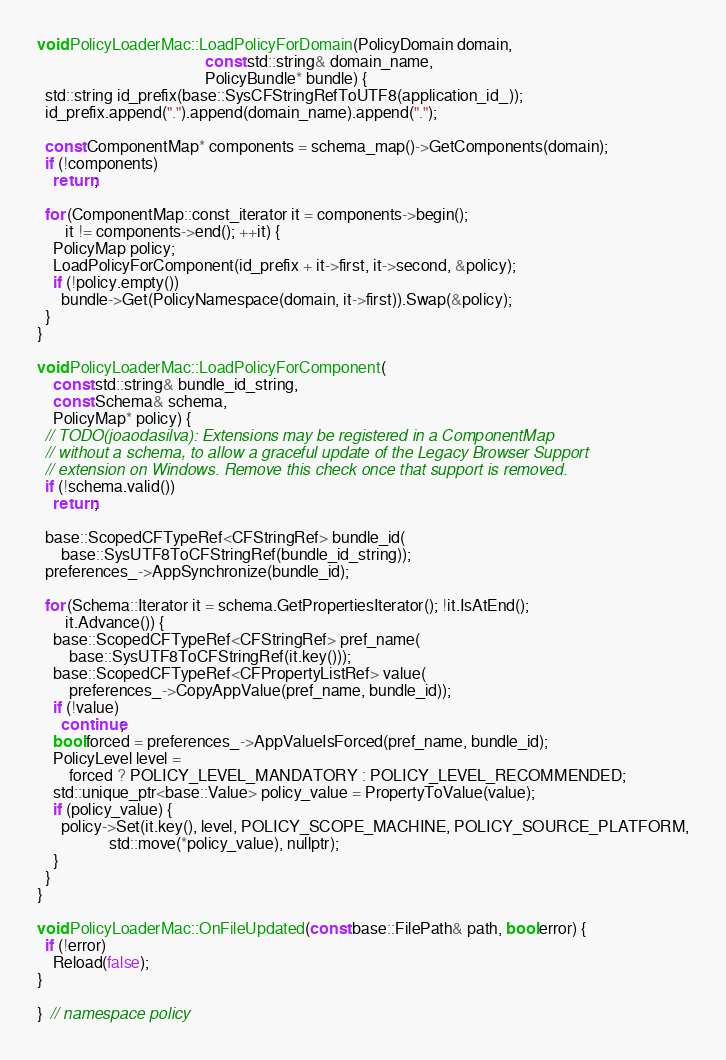Convert code to text. <code><loc_0><loc_0><loc_500><loc_500><_ObjectiveC_>void PolicyLoaderMac::LoadPolicyForDomain(PolicyDomain domain,
                                          const std::string& domain_name,
                                          PolicyBundle* bundle) {
  std::string id_prefix(base::SysCFStringRefToUTF8(application_id_));
  id_prefix.append(".").append(domain_name).append(".");

  const ComponentMap* components = schema_map()->GetComponents(domain);
  if (!components)
    return;

  for (ComponentMap::const_iterator it = components->begin();
       it != components->end(); ++it) {
    PolicyMap policy;
    LoadPolicyForComponent(id_prefix + it->first, it->second, &policy);
    if (!policy.empty())
      bundle->Get(PolicyNamespace(domain, it->first)).Swap(&policy);
  }
}

void PolicyLoaderMac::LoadPolicyForComponent(
    const std::string& bundle_id_string,
    const Schema& schema,
    PolicyMap* policy) {
  // TODO(joaodasilva): Extensions may be registered in a ComponentMap
  // without a schema, to allow a graceful update of the Legacy Browser Support
  // extension on Windows. Remove this check once that support is removed.
  if (!schema.valid())
    return;

  base::ScopedCFTypeRef<CFStringRef> bundle_id(
      base::SysUTF8ToCFStringRef(bundle_id_string));
  preferences_->AppSynchronize(bundle_id);

  for (Schema::Iterator it = schema.GetPropertiesIterator(); !it.IsAtEnd();
       it.Advance()) {
    base::ScopedCFTypeRef<CFStringRef> pref_name(
        base::SysUTF8ToCFStringRef(it.key()));
    base::ScopedCFTypeRef<CFPropertyListRef> value(
        preferences_->CopyAppValue(pref_name, bundle_id));
    if (!value)
      continue;
    bool forced = preferences_->AppValueIsForced(pref_name, bundle_id);
    PolicyLevel level =
        forced ? POLICY_LEVEL_MANDATORY : POLICY_LEVEL_RECOMMENDED;
    std::unique_ptr<base::Value> policy_value = PropertyToValue(value);
    if (policy_value) {
      policy->Set(it.key(), level, POLICY_SCOPE_MACHINE, POLICY_SOURCE_PLATFORM,
                  std::move(*policy_value), nullptr);
    }
  }
}

void PolicyLoaderMac::OnFileUpdated(const base::FilePath& path, bool error) {
  if (!error)
    Reload(false);
}

}  // namespace policy
</code> 